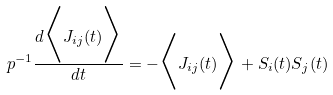Convert formula to latex. <formula><loc_0><loc_0><loc_500><loc_500>p ^ { - 1 } \frac { d \Big < J _ { i j } ( t ) \Big > } { d t } = - \Big < J _ { i j } ( t ) \Big > + S _ { i } ( t ) S _ { j } ( t )</formula> 